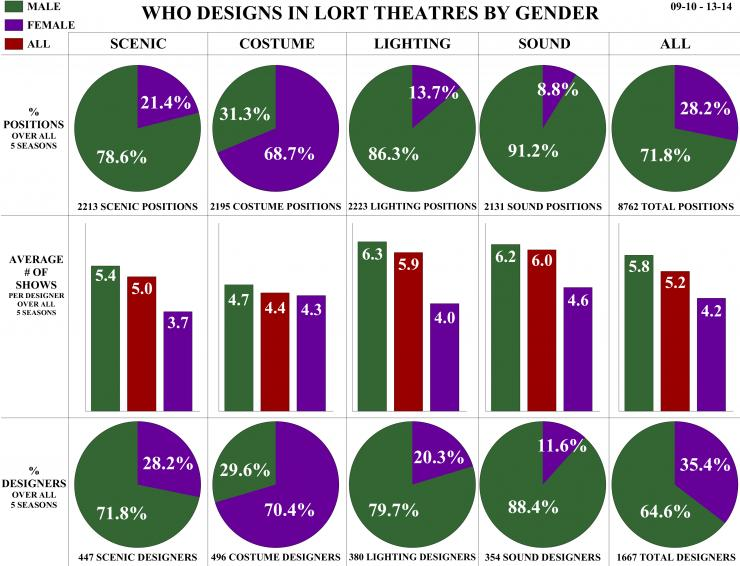Outline some significant characteristics in this image. According to the data, 28.2% of females hold total positions in the company. According to a recent survey, 70.4% of females are costume designers. Approximately 35.4% of females are designers, according to the data provided. According to the data, 31.3% of costume positions are held by men. According to the data, only 21.4% of scenic positions are held by females. 